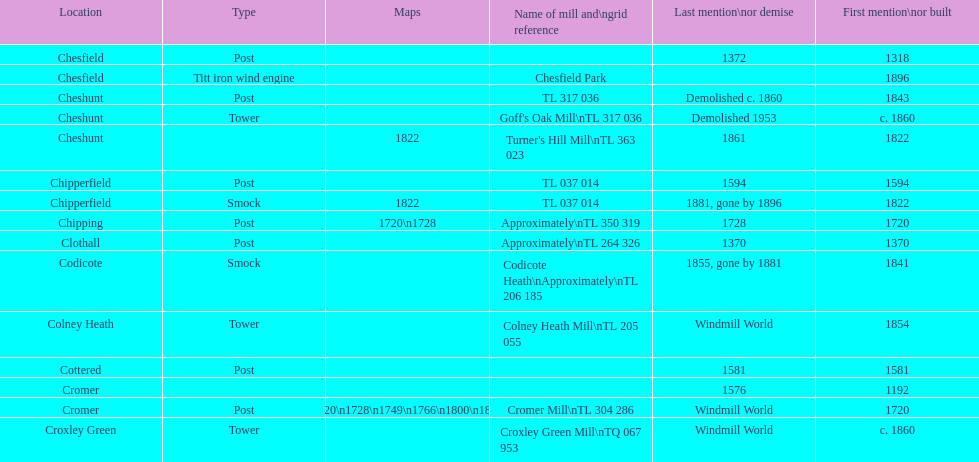What is the number of mills first mentioned or built in the 1800s? 8. 